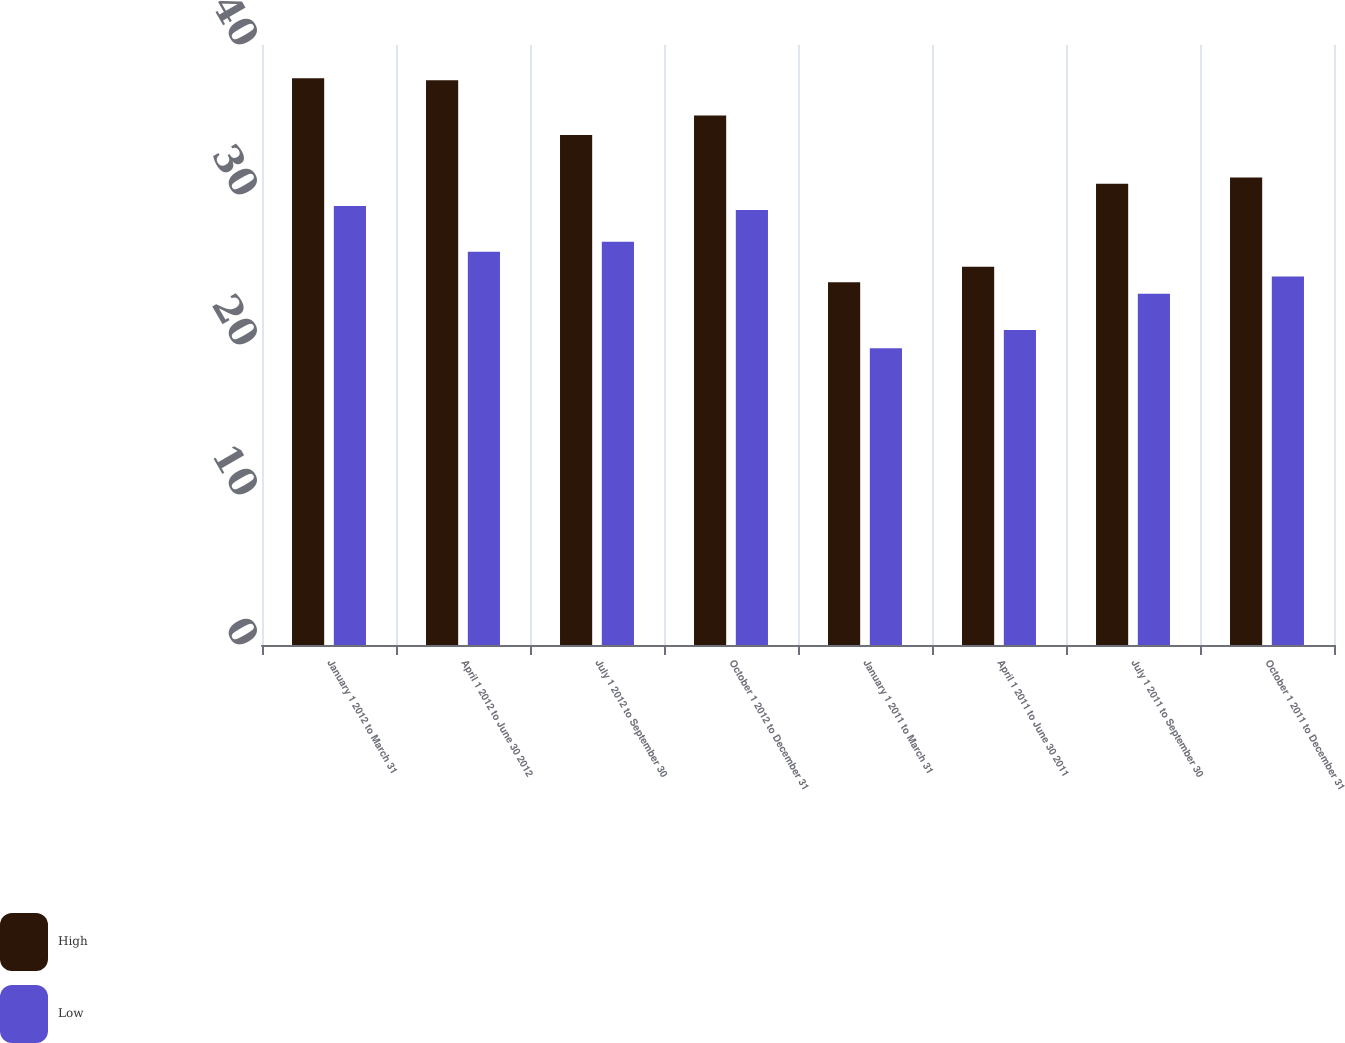Convert chart. <chart><loc_0><loc_0><loc_500><loc_500><stacked_bar_chart><ecel><fcel>January 1 2012 to March 31<fcel>April 1 2012 to June 30 2012<fcel>July 1 2012 to September 30<fcel>October 1 2012 to December 31<fcel>January 1 2011 to March 31<fcel>April 1 2011 to June 30 2011<fcel>July 1 2011 to September 30<fcel>October 1 2011 to December 31<nl><fcel>High<fcel>37.79<fcel>37.65<fcel>34<fcel>35.3<fcel>24.19<fcel>25.22<fcel>30.75<fcel>31.16<nl><fcel>Low<fcel>29.26<fcel>26.22<fcel>26.88<fcel>29<fcel>19.78<fcel>21<fcel>23.41<fcel>24.57<nl></chart> 